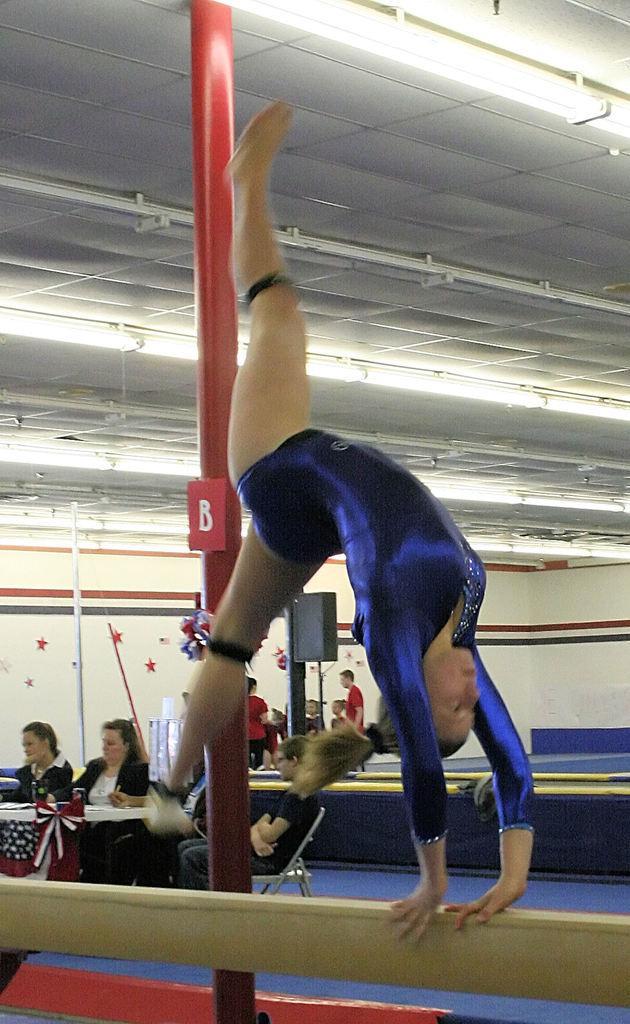Could you give a brief overview of what you see in this image? In this image there is a girl doing floor exercise, behind her there are a few people sat on their chair in front of the table. In the background there is a pole and few people are standing and there are few stars attached to the wall. At the top there is a ceiling. 